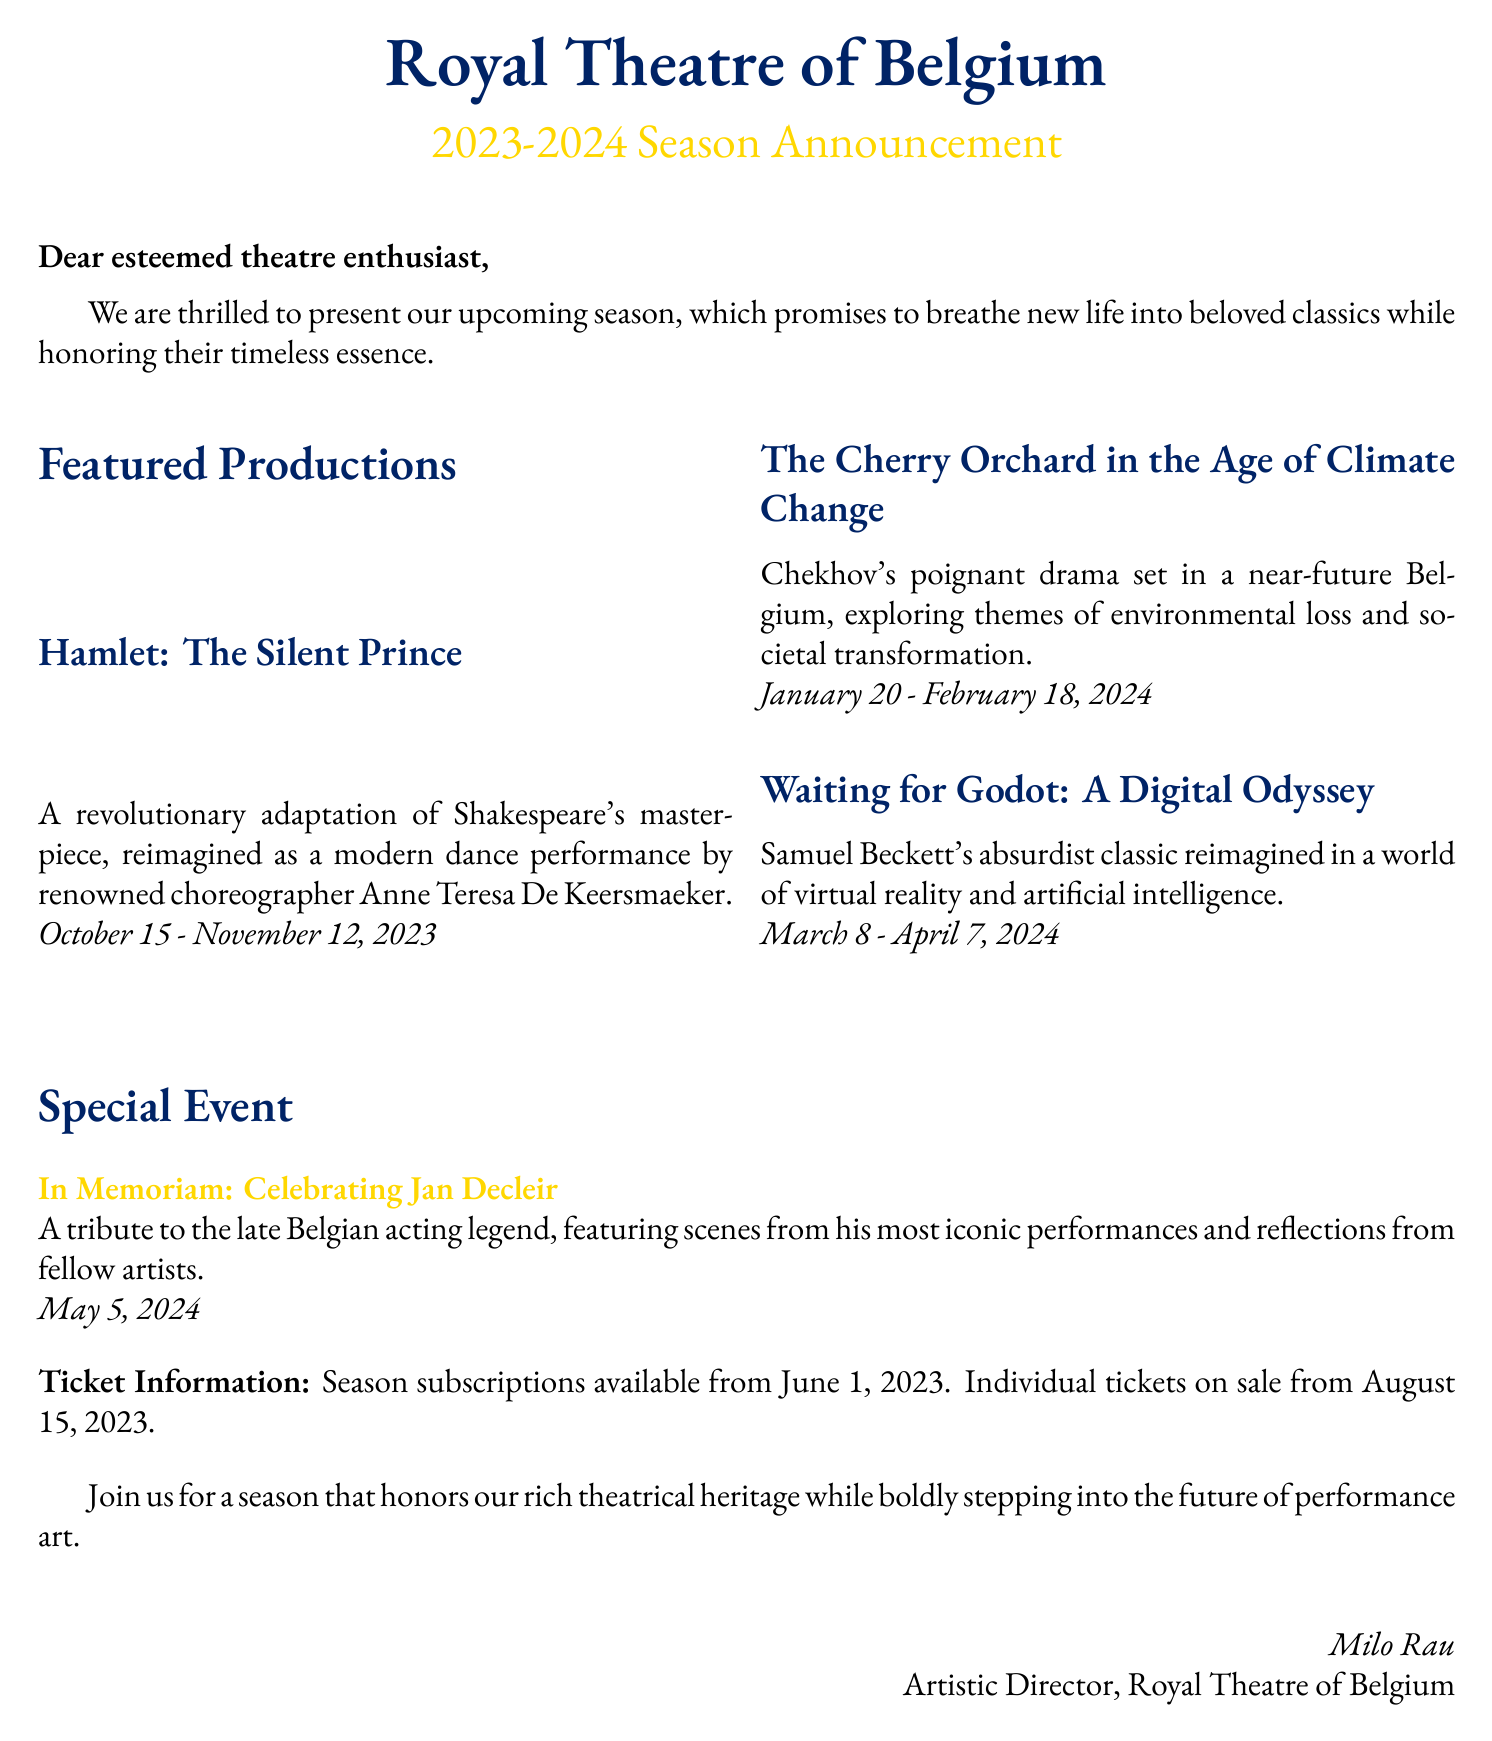What is the title of the first featured production? The first featured production is titled "Hamlet: The Silent Prince."
Answer: Hamlet: The Silent Prince What are the dates for "The Cherry Orchard in the Age of Climate Change"? The dates for this production are specified in the document.
Answer: January 20 - February 18, 2024 Who is the choreographer of "Hamlet: The Silent Prince"? The choreographer is mentioned as part of the production description.
Answer: Anne Teresa De Keersmaeker What is the special event scheduled for May 5, 2024? The special event is highlighted separately in the document.
Answer: In Memoriam: Celebrating Jan Decleir When do season subscriptions become available? The availability of season subscriptions is stated in the ticket information section.
Answer: June 1, 2023 What theme is explored in "The Cherry Orchard in the Age of Climate Change"? The theme is provided in the production description.
Answer: Environmental loss and societal transformation How many featured productions are announced for the upcoming season? The number of productions can be counted from the list provided.
Answer: Three What is the role of Milo Rau in this announcement? Milo Rau's position is stated at the bottom of the document.
Answer: Artistic Director 